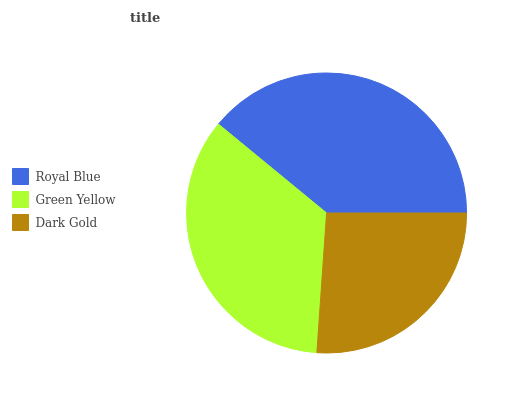Is Dark Gold the minimum?
Answer yes or no. Yes. Is Royal Blue the maximum?
Answer yes or no. Yes. Is Green Yellow the minimum?
Answer yes or no. No. Is Green Yellow the maximum?
Answer yes or no. No. Is Royal Blue greater than Green Yellow?
Answer yes or no. Yes. Is Green Yellow less than Royal Blue?
Answer yes or no. Yes. Is Green Yellow greater than Royal Blue?
Answer yes or no. No. Is Royal Blue less than Green Yellow?
Answer yes or no. No. Is Green Yellow the high median?
Answer yes or no. Yes. Is Green Yellow the low median?
Answer yes or no. Yes. Is Dark Gold the high median?
Answer yes or no. No. Is Dark Gold the low median?
Answer yes or no. No. 